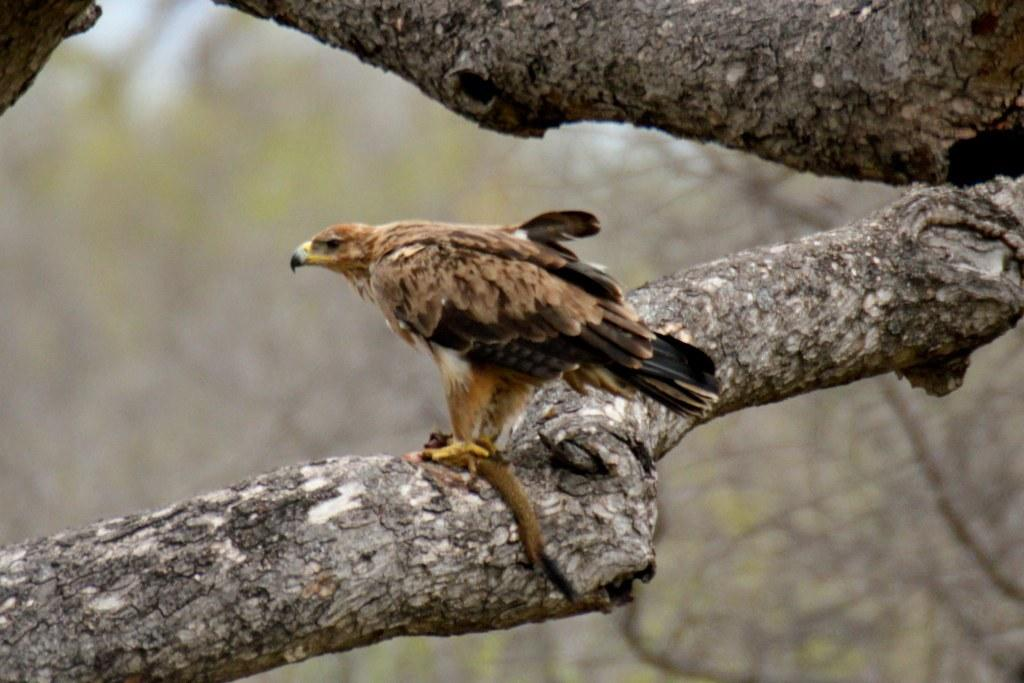What type of animal can be seen in the image? There is a bird visible in the image. Where is the bird located in the image? The bird is on the stem of a tree. How many books can be seen in the image? There are no books present in the image; it features a bird on the stem of a tree. What is the rate at which the bird is flying in the image? The image does not show the bird flying, so it is not possible to determine its rate of flight. 